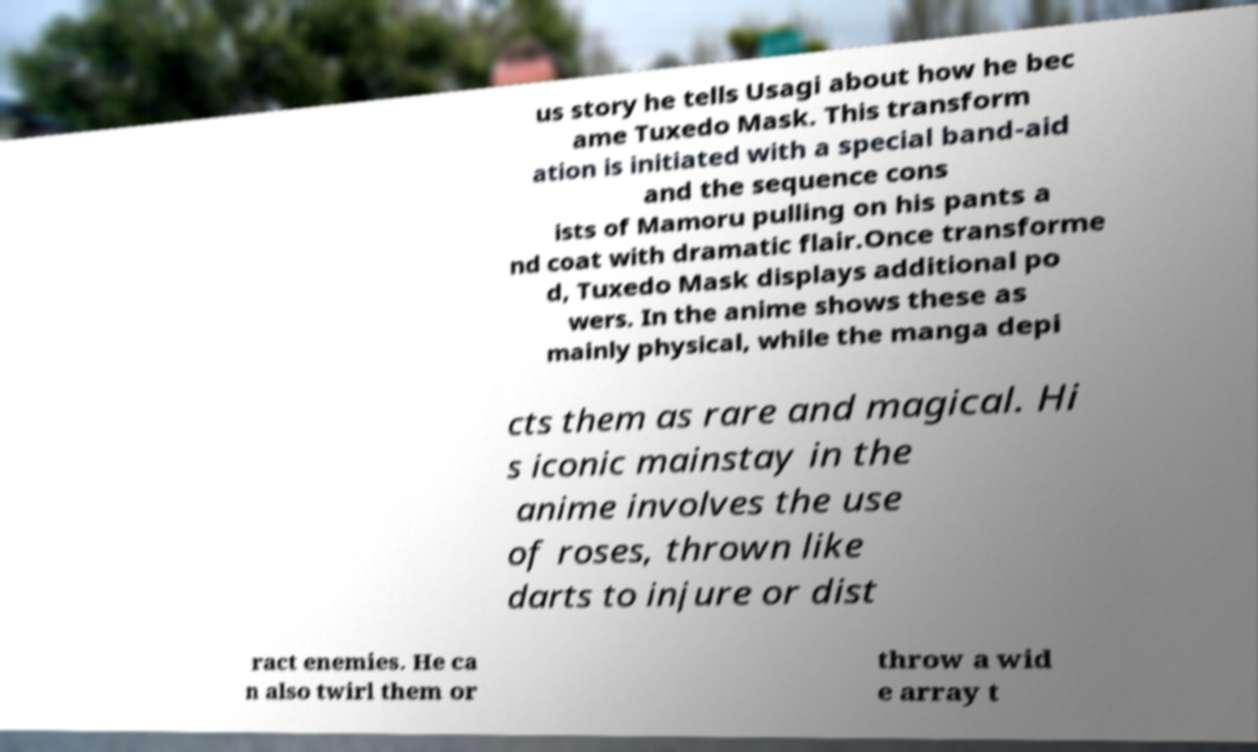Please read and relay the text visible in this image. What does it say? us story he tells Usagi about how he bec ame Tuxedo Mask. This transform ation is initiated with a special band-aid and the sequence cons ists of Mamoru pulling on his pants a nd coat with dramatic flair.Once transforme d, Tuxedo Mask displays additional po wers. In the anime shows these as mainly physical, while the manga depi cts them as rare and magical. Hi s iconic mainstay in the anime involves the use of roses, thrown like darts to injure or dist ract enemies. He ca n also twirl them or throw a wid e array t 